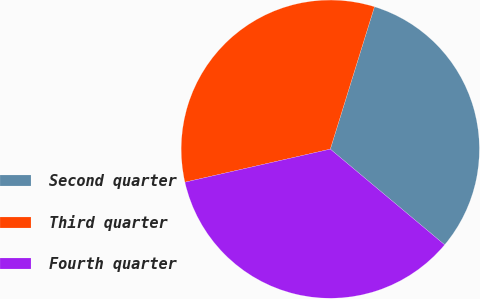Convert chart to OTSL. <chart><loc_0><loc_0><loc_500><loc_500><pie_chart><fcel>Second quarter<fcel>Third quarter<fcel>Fourth quarter<nl><fcel>31.3%<fcel>33.34%<fcel>35.35%<nl></chart> 